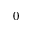<formula> <loc_0><loc_0><loc_500><loc_500>_ { 0 }</formula> 